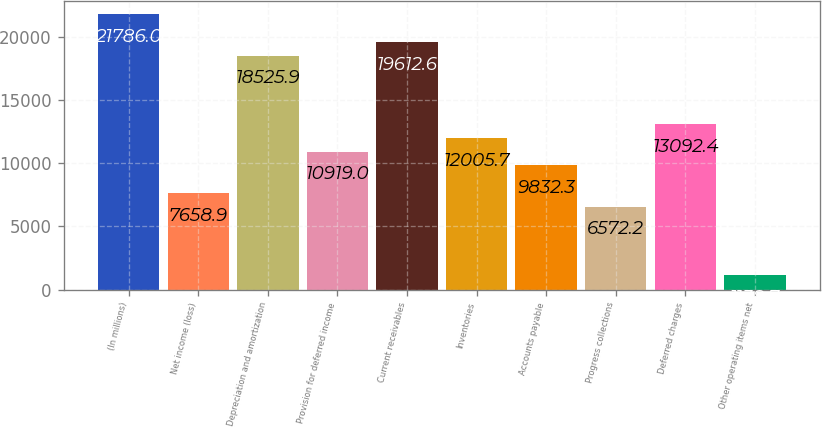<chart> <loc_0><loc_0><loc_500><loc_500><bar_chart><fcel>(In millions)<fcel>Net income (loss)<fcel>Depreciation and amortization<fcel>Provision for deferred income<fcel>Current receivables<fcel>Inventories<fcel>Accounts payable<fcel>Progress collections<fcel>Deferred charges<fcel>Other operating items net<nl><fcel>21786<fcel>7658.9<fcel>18525.9<fcel>10919<fcel>19612.6<fcel>12005.7<fcel>9832.3<fcel>6572.2<fcel>13092.4<fcel>1138.7<nl></chart> 